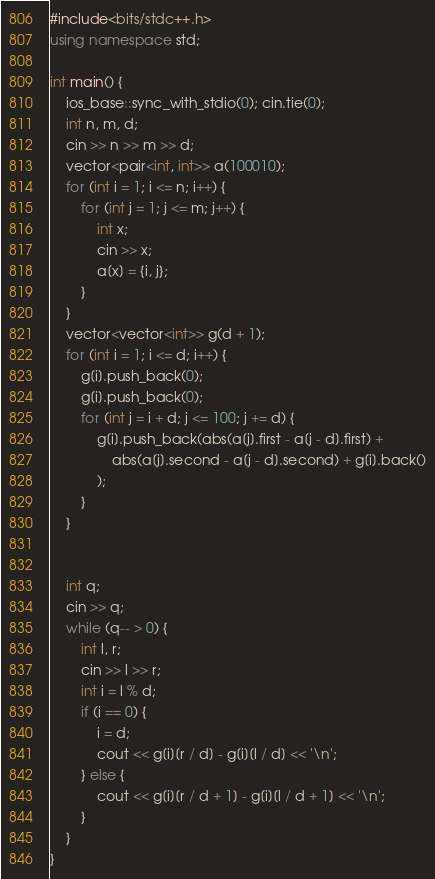Convert code to text. <code><loc_0><loc_0><loc_500><loc_500><_C++_>#include<bits/stdc++.h>
using namespace std;

int main() {
    ios_base::sync_with_stdio(0); cin.tie(0);
    int n, m, d;
    cin >> n >> m >> d;
    vector<pair<int, int>> a(100010);
    for (int i = 1; i <= n; i++) {
        for (int j = 1; j <= m; j++) {
            int x;
            cin >> x;
            a[x] = {i, j};
        }
    }
    vector<vector<int>> g(d + 1);
    for (int i = 1; i <= d; i++) {
        g[i].push_back(0);
        g[i].push_back(0);
        for (int j = i + d; j <= 100; j += d) {
            g[i].push_back(abs(a[j].first - a[j - d].first) + 
                abs(a[j].second - a[j - d].second) + g[i].back()
            );
        }
    }
    
    
    int q;
    cin >> q;
    while (q-- > 0) {
        int l, r;
        cin >> l >> r;
        int i = l % d;
        if (i == 0) {
            i = d;
            cout << g[i][r / d] - g[i][l / d] << '\n';
        } else {
            cout << g[i][r / d + 1] - g[i][l / d + 1] << '\n';
        }
    }
}</code> 